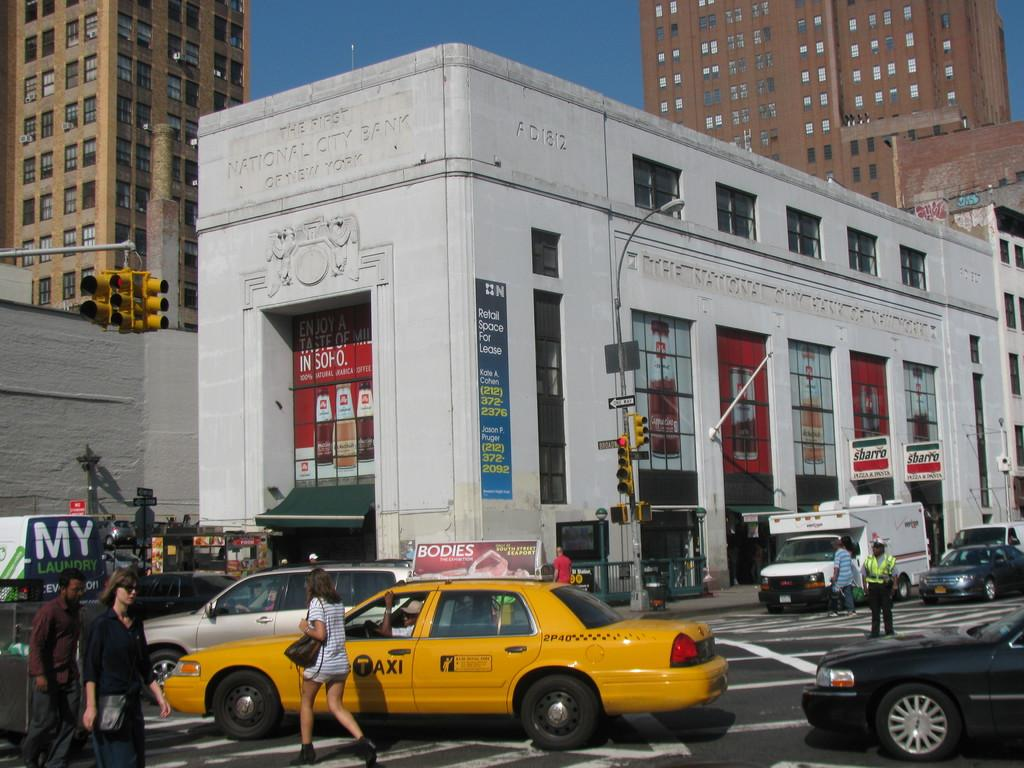<image>
Share a concise interpretation of the image provided. a taxi with the word bodies on it 